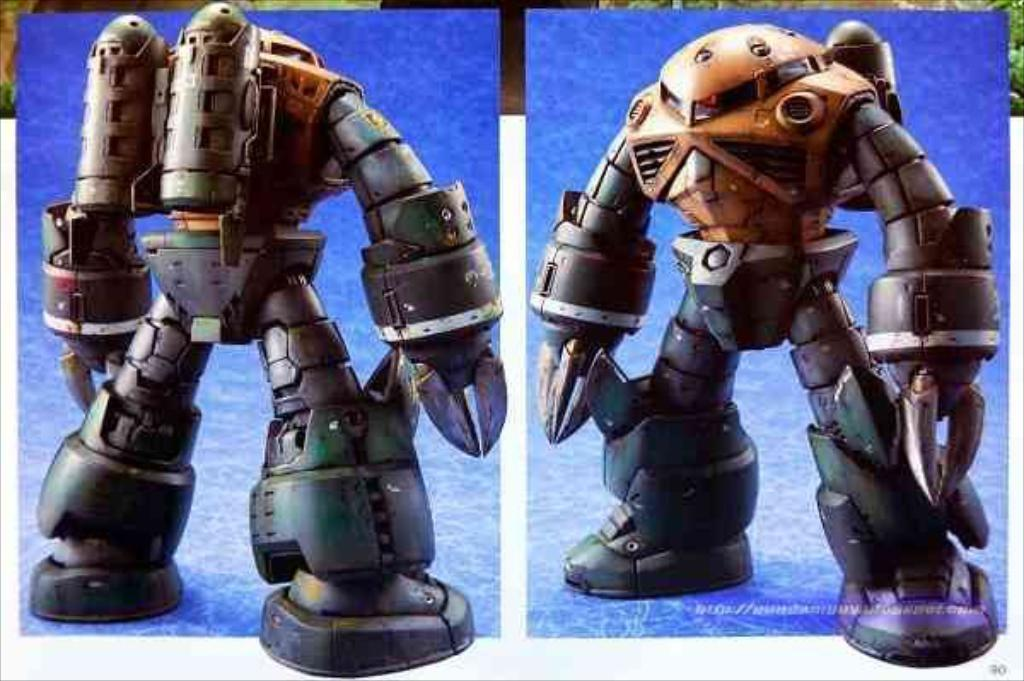What is depicted in the two pictures in the image? There are two pictures of toys in the image. What colors are predominant in the background of the image? The background is blue and white. Can you identify any additional features in the image? Yes, there is a watermark visible in the image. What type of bubble is being blown by the toy in the image? There is no bubble being blown by a toy in the image. Can you hear the secretary coughing in the background of the image? There is no audio component to the image, and no secretary or coughing is depicted. 